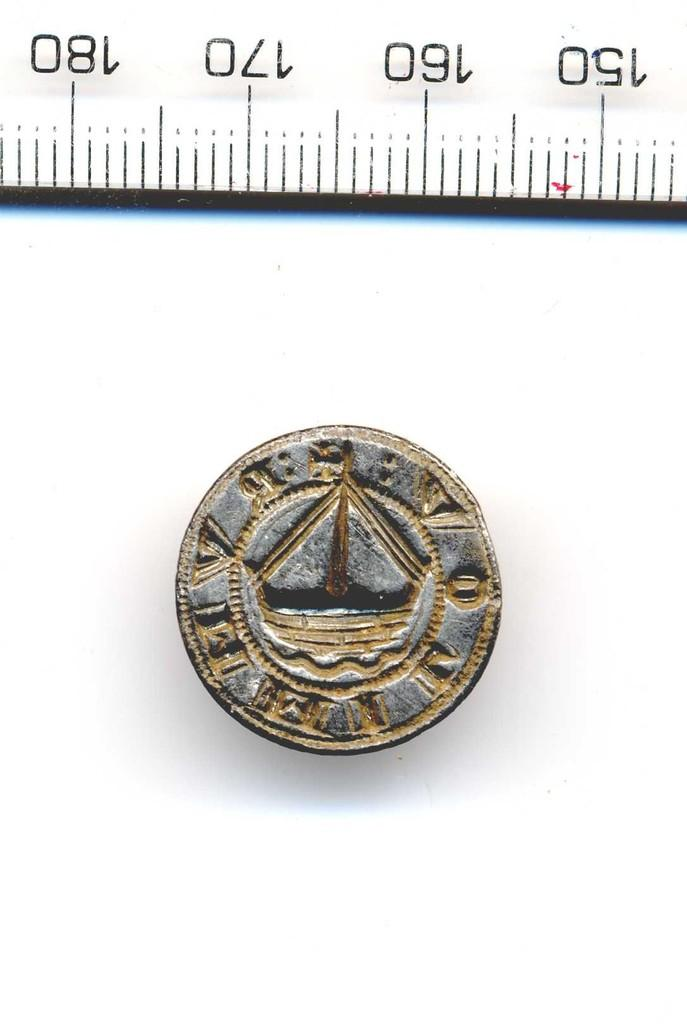<image>
Describe the image concisely. An old coin featuring a sailboat measure just under 20 mm. 